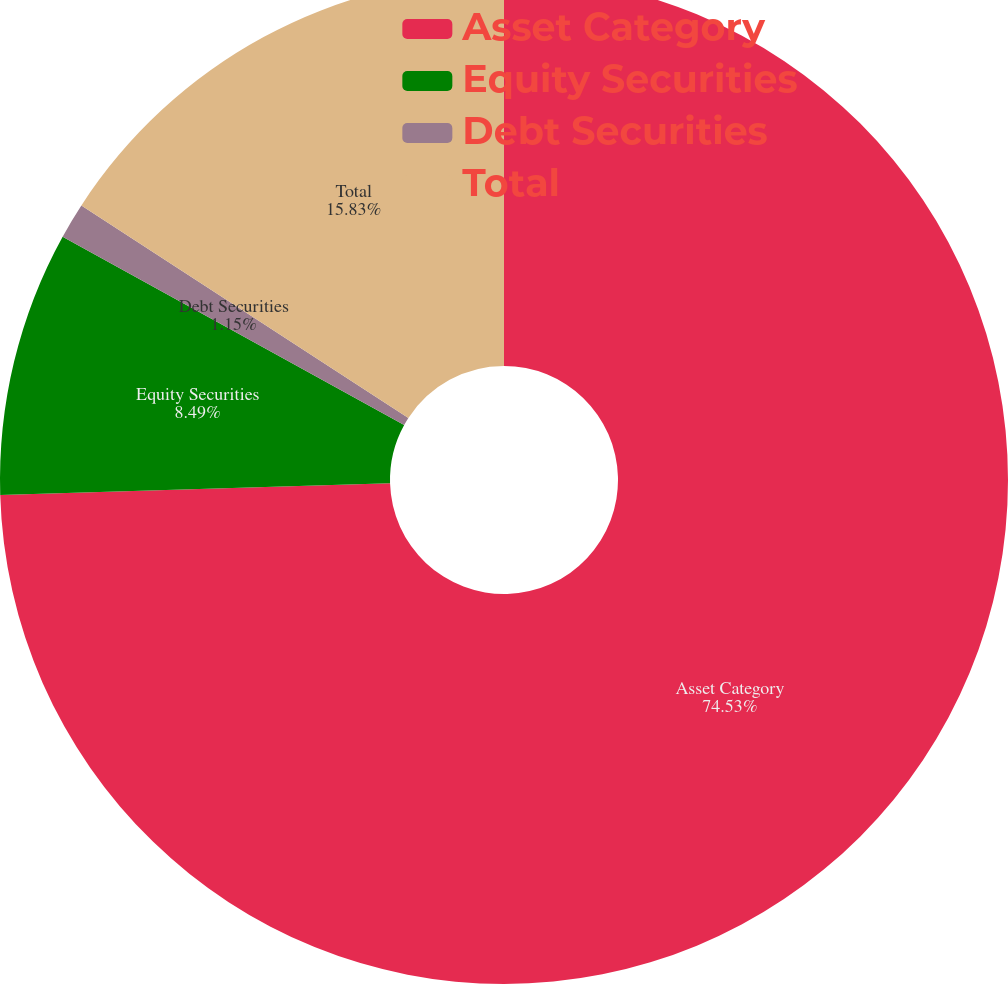Convert chart. <chart><loc_0><loc_0><loc_500><loc_500><pie_chart><fcel>Asset Category<fcel>Equity Securities<fcel>Debt Securities<fcel>Total<nl><fcel>74.53%<fcel>8.49%<fcel>1.15%<fcel>15.83%<nl></chart> 